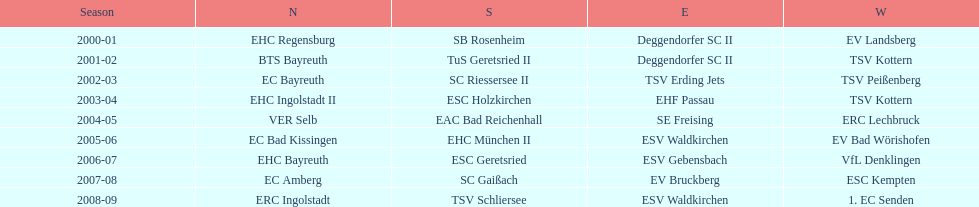Which name appears more often, kottern or bayreuth? Bayreuth. 